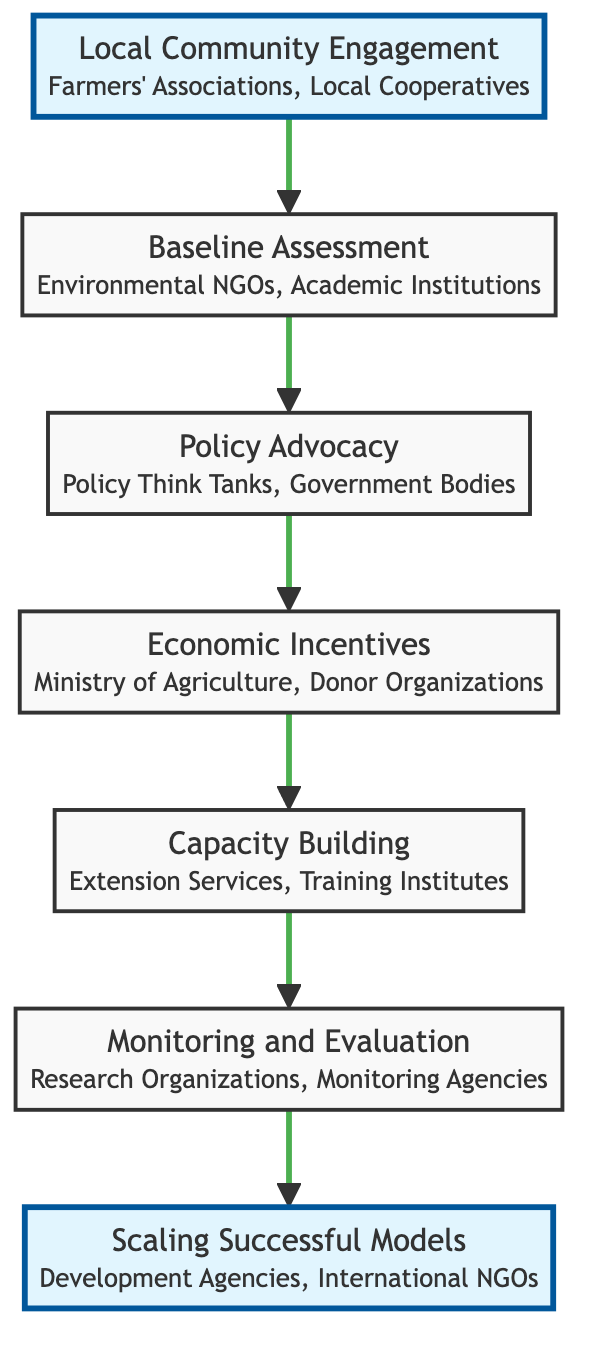What is the first step in the flow chart? The first step in the flow chart is "Local Community Engagement." This is indicated as the starting point in the diagram, which points upwards to the next step.
Answer: Local Community Engagement How many nodes are in the diagram? By counting each distinct labeled section (node) in the flow chart, we find there are seven nodes: Local Community Engagement, Baseline Assessment, Policy Advocacy, Economic Incentives, Capacity Building, Monitoring and Evaluation, and Scaling Successful Models.
Answer: Seven What is the last step in the flow chart? The last step in the flow chart is "Scaling Successful Models." This is presented at the top of the diagram, showing the final outcome of the policy changes progression.
Answer: Scaling Successful Models Which entities are associated with Capacity Building? The node "Capacity Building" lists its associated entities as "Extension Services" and "Environmental Training Institutes," which are specified directly in the diagram.
Answer: Extension Services, Environmental Training Institutes What flows into Monitoring and Evaluation? "Capacity Building" flows into "Monitoring and Evaluation" as the preceding step in the diagram, indicating a sequential relationship between these two nodes.
Answer: Capacity Building Identify two elements directly leading to Economic Incentives. The two elements that directly lead to "Economic Incentives" are "Policy Advocacy" and the steps before them, "Baseline Assessment." This shows the order of steps leading to the implementation of economic incentives.
Answer: Baseline Assessment, Policy Advocacy What is the relationship between Local Community Engagement and Baseline Assessment? The relationship shown in the diagram indicates that "Local Community Engagement" is the first step and it flows into "Baseline Assessment," meaning it precedes and informs the next action.
Answer: Local Community Engagement leads to Baseline Assessment What type of changes does Policy Advocacy promote? "Policy Advocacy" promotes changes in local, regional, and national policies aimed at supporting sustainable practices, as described in the corresponding section of the diagram.
Answer: Changes in policies What are the main types of entities working on Economic Incentives? The entities associated with "Economic Incentives" are "Ministry of Agriculture" and "International Donor Organizations" as specified in the flow chart.
Answer: Ministry of Agriculture, International Donor Organizations 